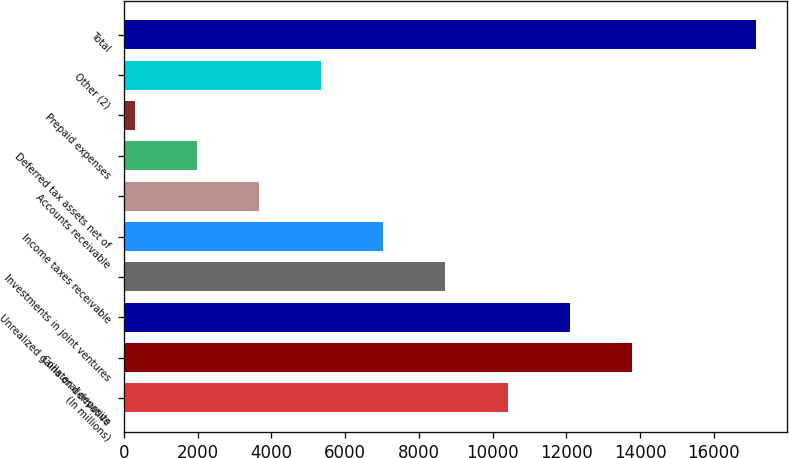<chart> <loc_0><loc_0><loc_500><loc_500><bar_chart><fcel>(In millions)<fcel>Collateral deposits<fcel>Unrealized gains on derivative<fcel>Investments in joint ventures<fcel>Income taxes receivable<fcel>Accounts receivable<fcel>Deferred tax assets net of<fcel>Prepaid expenses<fcel>Other (2)<fcel>Total<nl><fcel>10406.6<fcel>13772.8<fcel>12089.7<fcel>8723.5<fcel>7040.4<fcel>3674.2<fcel>1991.1<fcel>308<fcel>5357.3<fcel>17139<nl></chart> 